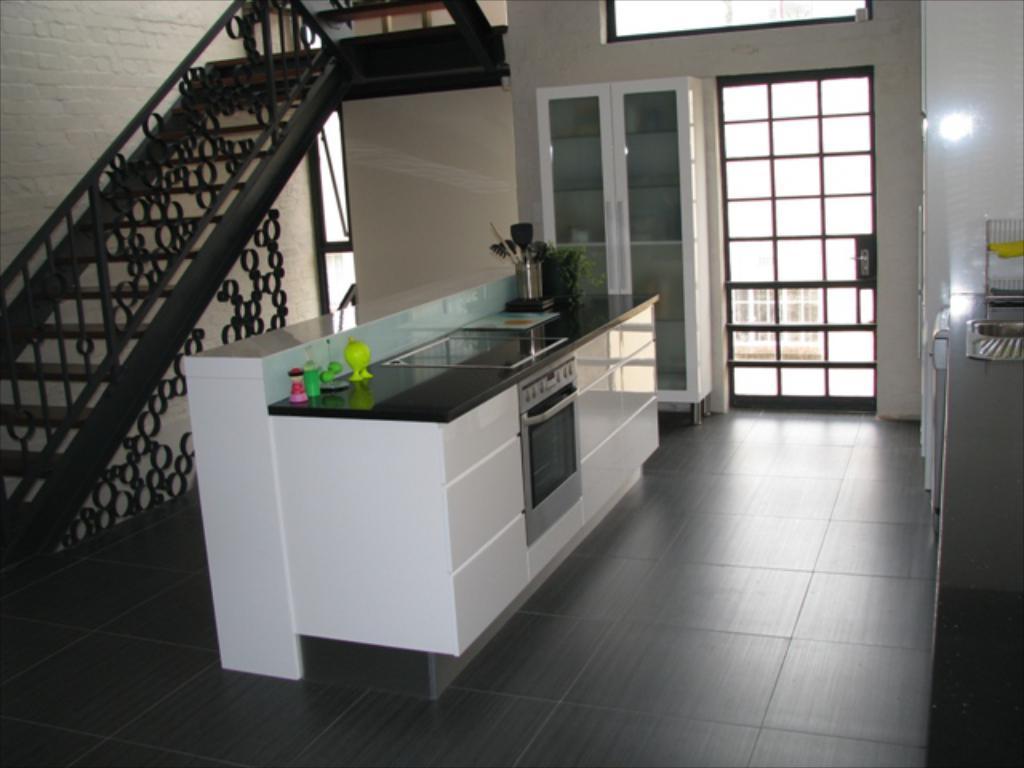Describe this image in one or two sentences. In the foreground I can see a cabinet, bottles and a houseplant. In the background I can see a cupboard, window, wall and a staircase. This image is taken may be in a room. 